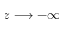Convert formula to latex. <formula><loc_0><loc_0><loc_500><loc_500>z \longrightarrow - \infty</formula> 